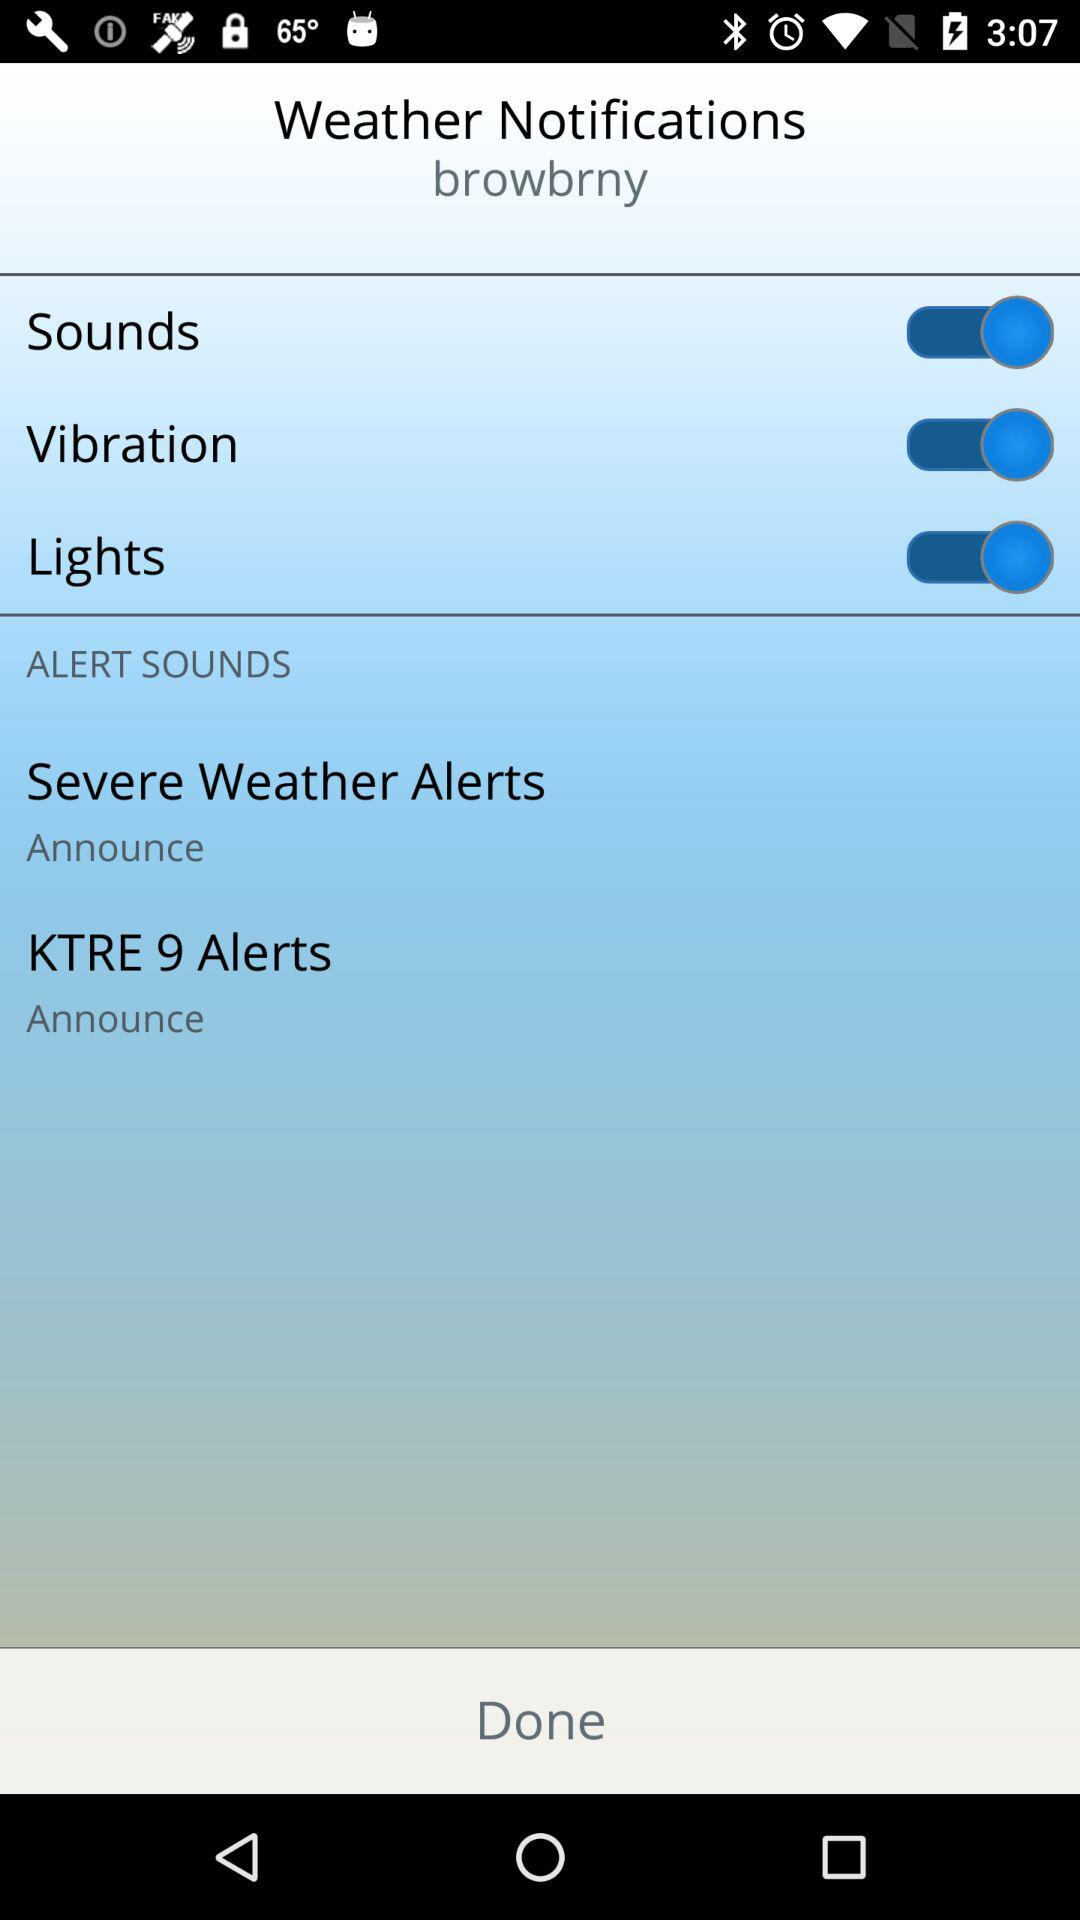Which options are enabled? The enabled options are "Sounds", "Vibration" and "Lights". 